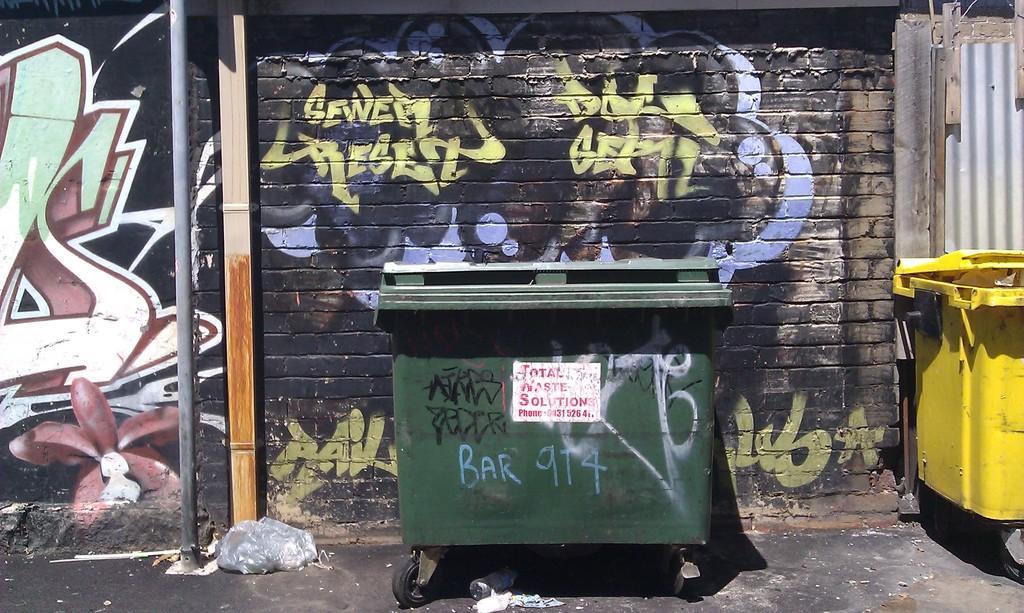Can you describe this image briefly? In this image I can see a bin which in green in color and a white colored poster attached to it and a yellow colored bin on the ground. In the background I can see the wall which is black, yellow, violet, white , red and green in color, a metal pole and a wooden pole which is cream and brown in color. 